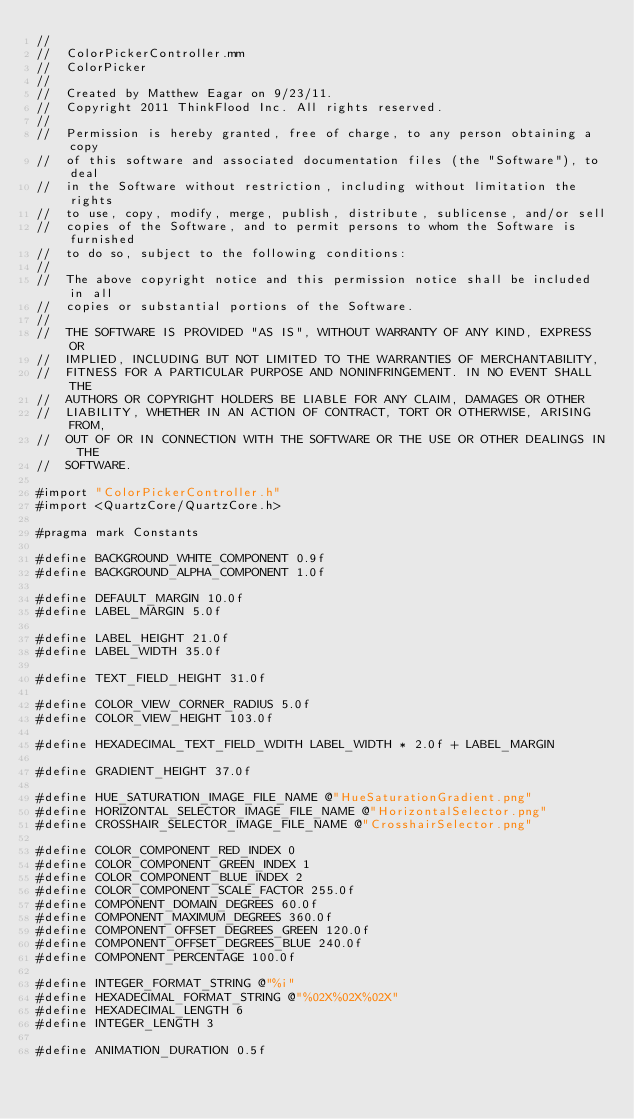Convert code to text. <code><loc_0><loc_0><loc_500><loc_500><_ObjectiveC_>//
//  ColorPickerController.mm
//  ColorPicker
//
//  Created by Matthew Eagar on 9/23/11.
//  Copyright 2011 ThinkFlood Inc. All rights reserved.
//
//  Permission is hereby granted, free of charge, to any person obtaining a copy 
//  of this software and associated documentation files (the "Software"), to deal 
//  in the Software without restriction, including without limitation the rights 
//  to use, copy, modify, merge, publish, distribute, sublicense, and/or sell 
//  copies of the Software, and to permit persons to whom the Software is furnished 
//  to do so, subject to the following conditions:
//
//  The above copyright notice and this permission notice shall be included in all 
//  copies or substantial portions of the Software.
//
//  THE SOFTWARE IS PROVIDED "AS IS", WITHOUT WARRANTY OF ANY KIND, EXPRESS OR 
//  IMPLIED, INCLUDING BUT NOT LIMITED TO THE WARRANTIES OF MERCHANTABILITY, 
//  FITNESS FOR A PARTICULAR PURPOSE AND NONINFRINGEMENT. IN NO EVENT SHALL THE 
//  AUTHORS OR COPYRIGHT HOLDERS BE LIABLE FOR ANY CLAIM, DAMAGES OR OTHER 
//  LIABILITY, WHETHER IN AN ACTION OF CONTRACT, TORT OR OTHERWISE, ARISING FROM, 
//  OUT OF OR IN CONNECTION WITH THE SOFTWARE OR THE USE OR OTHER DEALINGS IN THE 
//  SOFTWARE.

#import "ColorPickerController.h"
#import <QuartzCore/QuartzCore.h>

#pragma mark Constants

#define BACKGROUND_WHITE_COMPONENT 0.9f
#define BACKGROUND_ALPHA_COMPONENT 1.0f

#define DEFAULT_MARGIN 10.0f
#define LABEL_MARGIN 5.0f

#define LABEL_HEIGHT 21.0f
#define LABEL_WIDTH 35.0f

#define TEXT_FIELD_HEIGHT 31.0f

#define COLOR_VIEW_CORNER_RADIUS 5.0f
#define COLOR_VIEW_HEIGHT 103.0f

#define HEXADECIMAL_TEXT_FIELD_WDITH LABEL_WIDTH * 2.0f + LABEL_MARGIN

#define GRADIENT_HEIGHT 37.0f

#define HUE_SATURATION_IMAGE_FILE_NAME @"HueSaturationGradient.png"
#define HORIZONTAL_SELECTOR_IMAGE_FILE_NAME @"HorizontalSelector.png"
#define CROSSHAIR_SELECTOR_IMAGE_FILE_NAME @"CrosshairSelector.png"

#define COLOR_COMPONENT_RED_INDEX 0
#define COLOR_COMPONENT_GREEN_INDEX 1
#define COLOR_COMPONENT_BLUE_INDEX 2
#define COLOR_COMPONENT_SCALE_FACTOR 255.0f
#define COMPONENT_DOMAIN_DEGREES 60.0f
#define COMPONENT_MAXIMUM_DEGREES 360.0f
#define COMPONENT_OFFSET_DEGREES_GREEN 120.0f
#define COMPONENT_OFFSET_DEGREES_BLUE 240.0f
#define COMPONENT_PERCENTAGE 100.0f

#define INTEGER_FORMAT_STRING @"%i"
#define HEXADECIMAL_FORMAT_STRING @"%02X%02X%02X"
#define HEXADECIMAL_LENGTH 6
#define INTEGER_LENGTH 3

#define ANIMATION_DURATION 0.5f
</code> 